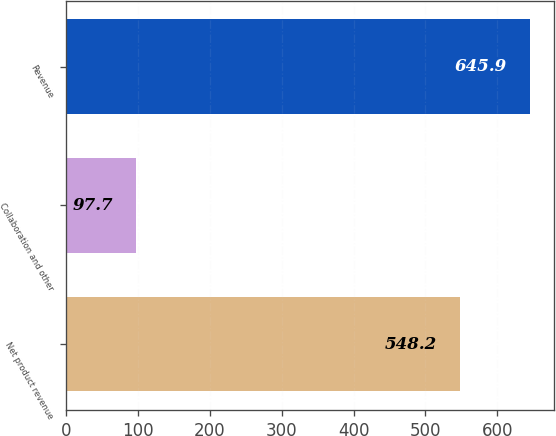Convert chart. <chart><loc_0><loc_0><loc_500><loc_500><bar_chart><fcel>Net product revenue<fcel>Collaboration and other<fcel>Revenue<nl><fcel>548.2<fcel>97.7<fcel>645.9<nl></chart> 